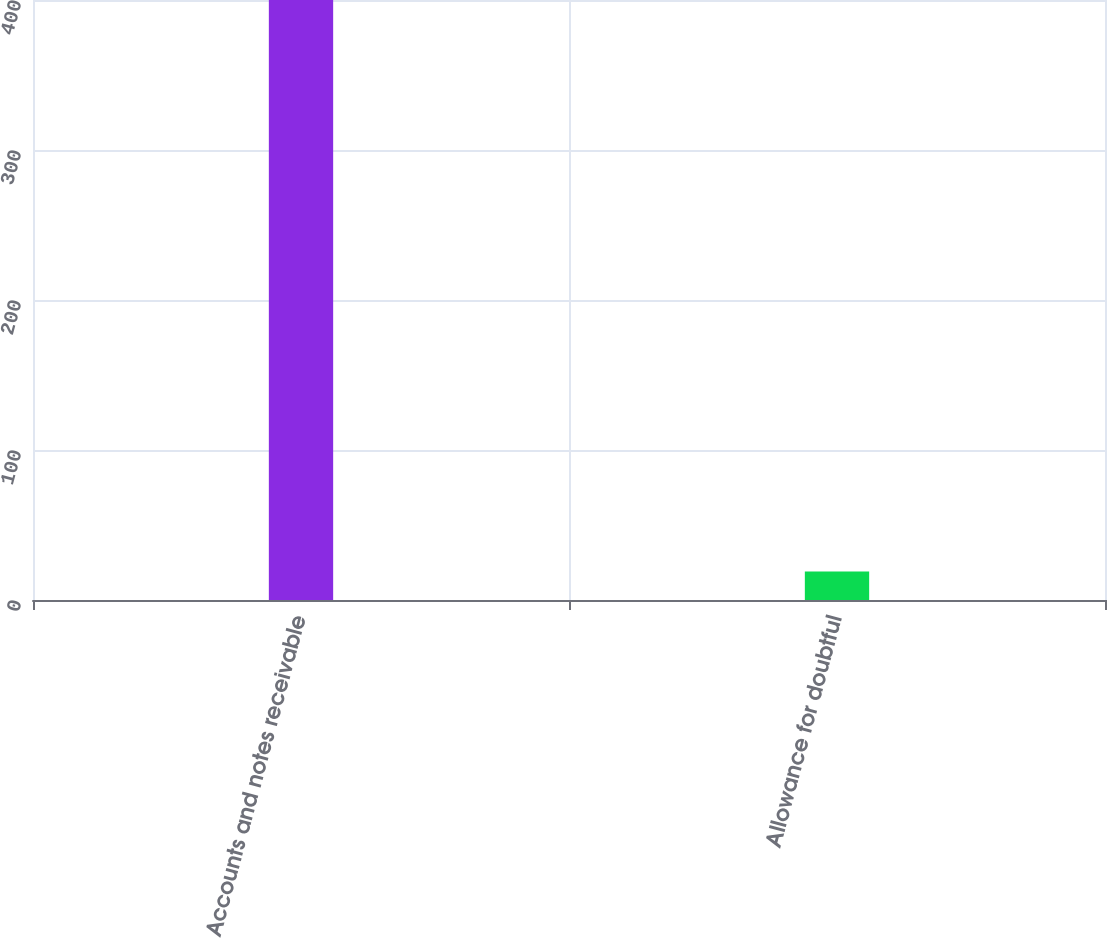<chart> <loc_0><loc_0><loc_500><loc_500><bar_chart><fcel>Accounts and notes receivable<fcel>Allowance for doubtful<nl><fcel>400<fcel>19<nl></chart> 